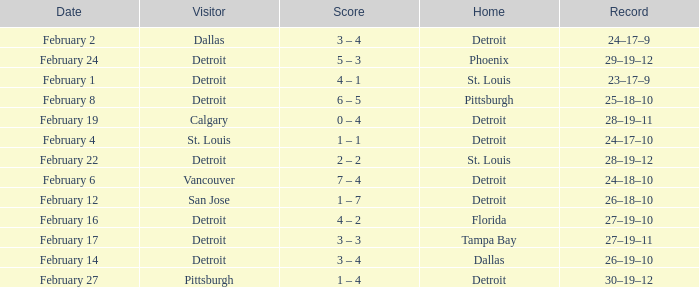What was their record on February 24? 29–19–12. 